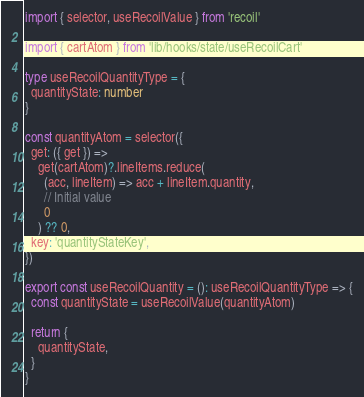<code> <loc_0><loc_0><loc_500><loc_500><_TypeScript_>import { selector, useRecoilValue } from 'recoil'

import { cartAtom } from 'lib/hooks/state/useRecoilCart'

type useRecoilQuantityType = {
  quantityState: number
}

const quantityAtom = selector({
  get: ({ get }) =>
    get(cartAtom)?.lineItems.reduce(
      (acc, lineItem) => acc + lineItem.quantity,
      // Initial value
      0
    ) ?? 0,
  key: 'quantityStateKey',
})

export const useRecoilQuantity = (): useRecoilQuantityType => {
  const quantityState = useRecoilValue(quantityAtom)

  return {
    quantityState,
  }
}
</code> 